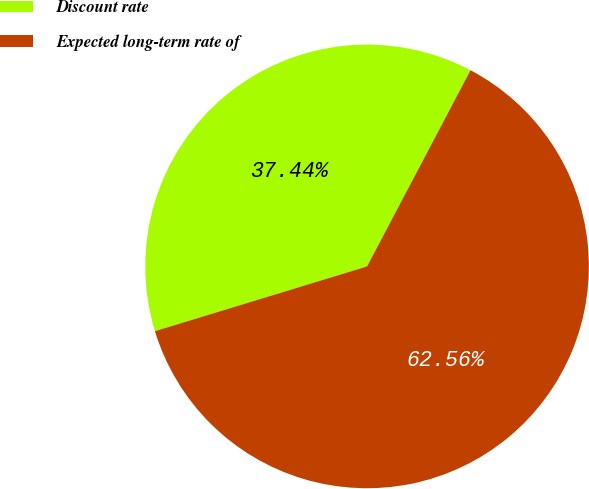Convert chart to OTSL. <chart><loc_0><loc_0><loc_500><loc_500><pie_chart><fcel>Discount rate<fcel>Expected long-term rate of<nl><fcel>37.44%<fcel>62.56%<nl></chart> 